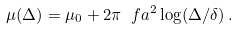Convert formula to latex. <formula><loc_0><loc_0><loc_500><loc_500>\mu ( \Delta ) = \mu _ { 0 } + 2 \pi \ f a ^ { 2 } \log ( \Delta / \delta ) \, .</formula> 